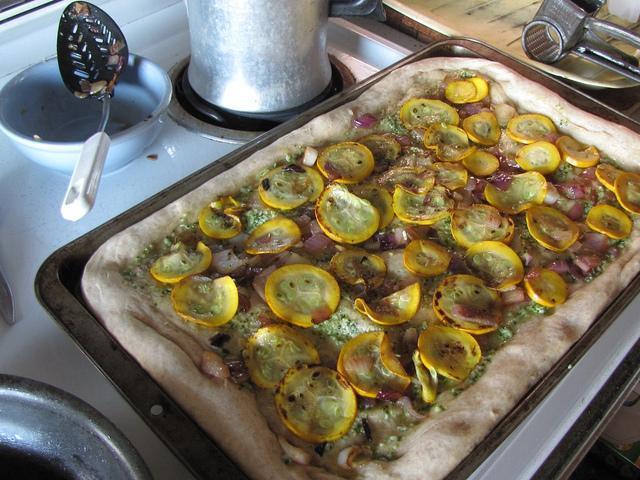Is the statement "The pizza is inside the oven." accurate regarding the image?
Answer yes or no. No. 